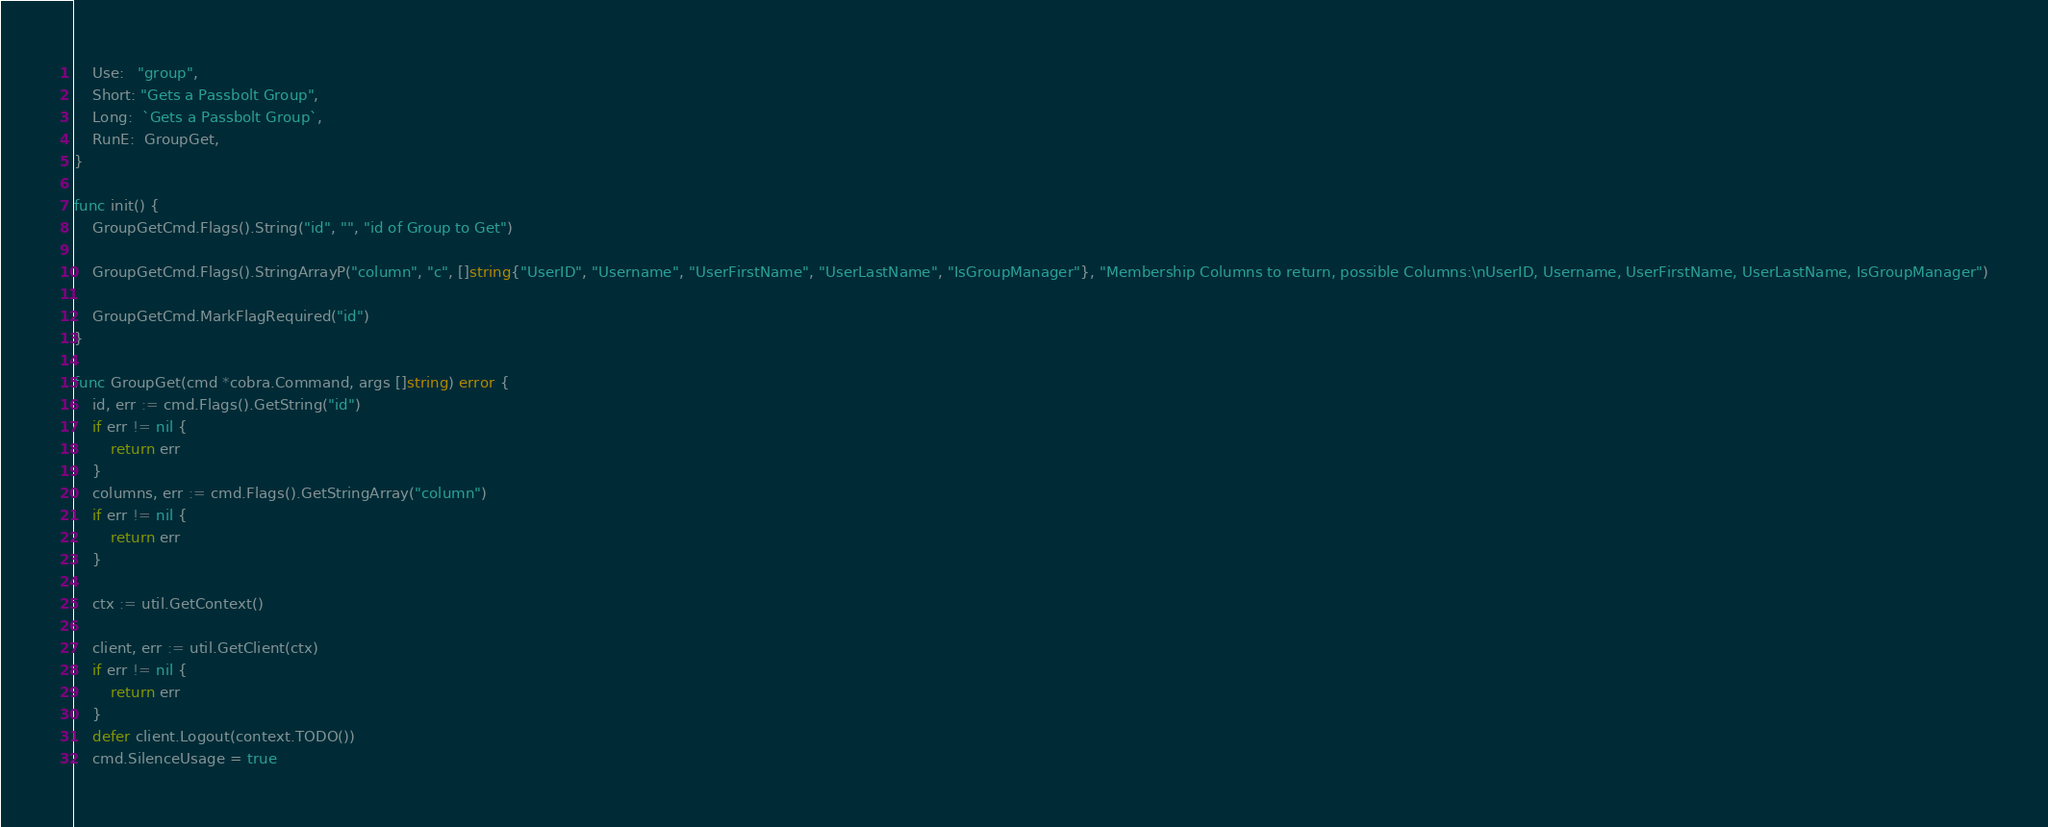Convert code to text. <code><loc_0><loc_0><loc_500><loc_500><_Go_>	Use:   "group",
	Short: "Gets a Passbolt Group",
	Long:  `Gets a Passbolt Group`,
	RunE:  GroupGet,
}

func init() {
	GroupGetCmd.Flags().String("id", "", "id of Group to Get")

	GroupGetCmd.Flags().StringArrayP("column", "c", []string{"UserID", "Username", "UserFirstName", "UserLastName", "IsGroupManager"}, "Membership Columns to return, possible Columns:\nUserID, Username, UserFirstName, UserLastName, IsGroupManager")

	GroupGetCmd.MarkFlagRequired("id")
}

func GroupGet(cmd *cobra.Command, args []string) error {
	id, err := cmd.Flags().GetString("id")
	if err != nil {
		return err
	}
	columns, err := cmd.Flags().GetStringArray("column")
	if err != nil {
		return err
	}

	ctx := util.GetContext()

	client, err := util.GetClient(ctx)
	if err != nil {
		return err
	}
	defer client.Logout(context.TODO())
	cmd.SilenceUsage = true
</code> 